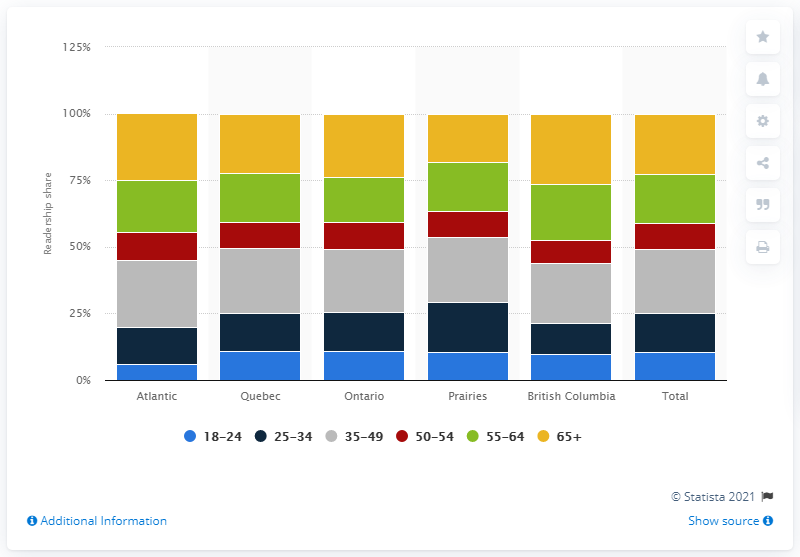Identify some key points in this picture. The readership share of individuals between the ages of 35 and 49 across all regions in Canada in June 2015 was 23.74%. 